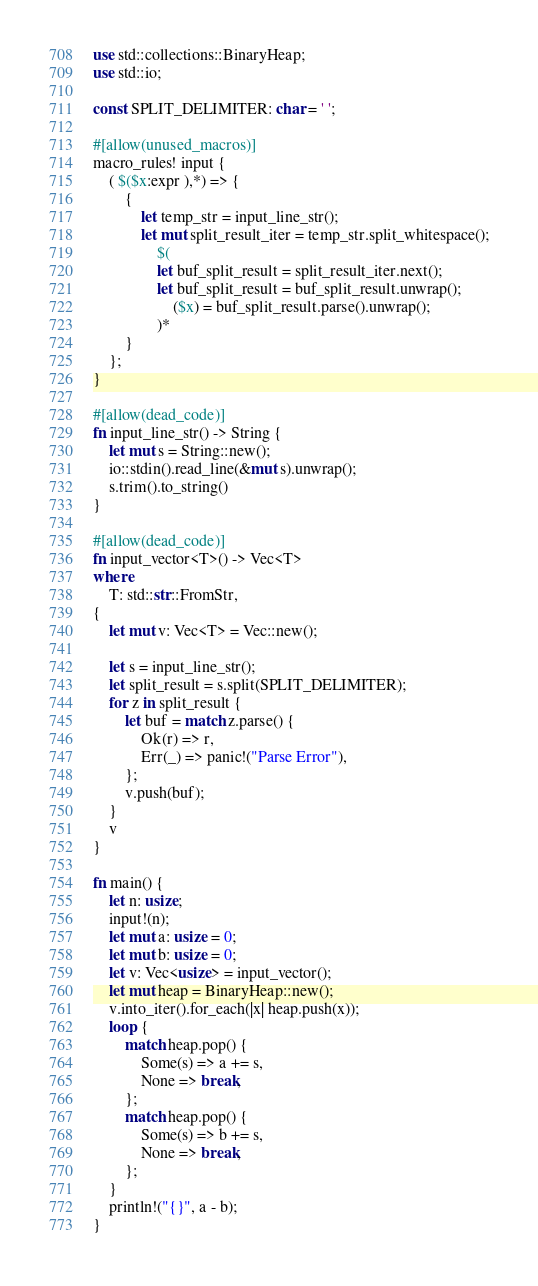Convert code to text. <code><loc_0><loc_0><loc_500><loc_500><_Rust_>use std::collections::BinaryHeap;
use std::io;

const SPLIT_DELIMITER: char = ' ';

#[allow(unused_macros)]
macro_rules! input {
    ( $($x:expr ),*) => {
        {
            let temp_str = input_line_str();
            let mut split_result_iter = temp_str.split_whitespace();
                $(
                let buf_split_result = split_result_iter.next();
                let buf_split_result = buf_split_result.unwrap();
                    ($x) = buf_split_result.parse().unwrap();
                )*
        }
    };
}

#[allow(dead_code)]
fn input_line_str() -> String {
    let mut s = String::new();
    io::stdin().read_line(&mut s).unwrap();
    s.trim().to_string()
}

#[allow(dead_code)]
fn input_vector<T>() -> Vec<T>
where
    T: std::str::FromStr,
{
    let mut v: Vec<T> = Vec::new();

    let s = input_line_str();
    let split_result = s.split(SPLIT_DELIMITER);
    for z in split_result {
        let buf = match z.parse() {
            Ok(r) => r,
            Err(_) => panic!("Parse Error"),
        };
        v.push(buf);
    }
    v
}

fn main() {
    let n: usize;
    input!(n);
    let mut a: usize = 0;
    let mut b: usize = 0;
    let v: Vec<usize> = input_vector();
    let mut heap = BinaryHeap::new();
    v.into_iter().for_each(|x| heap.push(x));
    loop {
        match heap.pop() {
            Some(s) => a += s,
            None => break,
        };
        match heap.pop() {
            Some(s) => b += s,
            None => break,
        };
    }
    println!("{}", a - b);
}</code> 